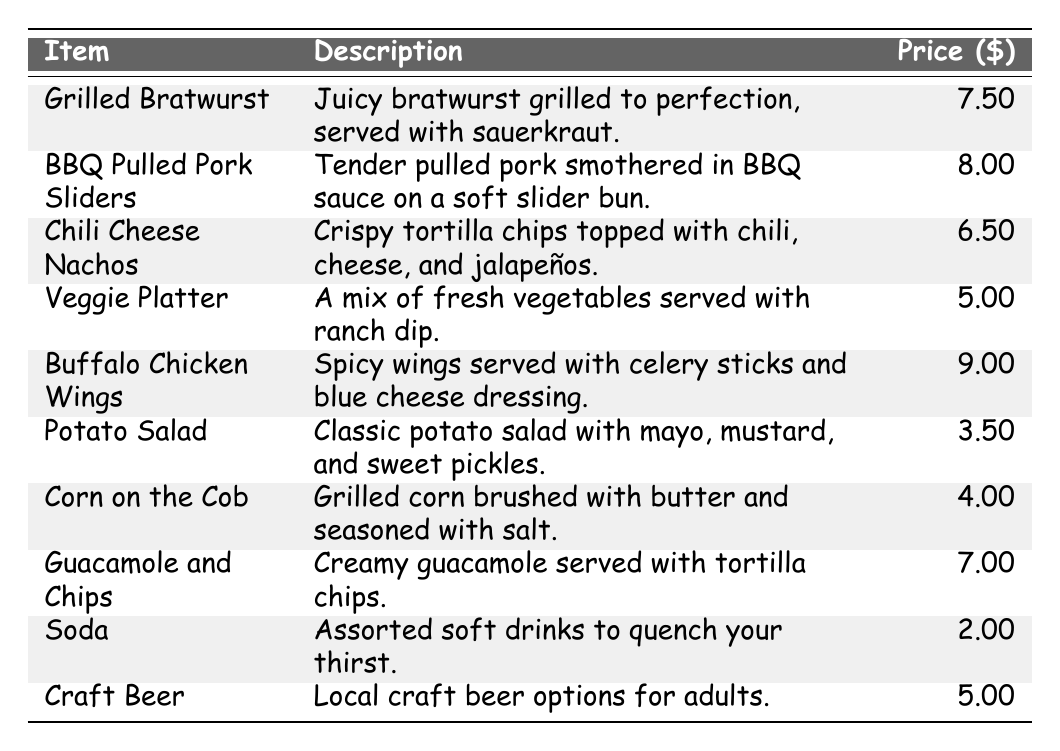What is the price of the Grilled Bratwurst? The table shows that the price listed next to Grilled Bratwurst is $7.50.
Answer: $7.50 How much do the BBQ Pulled Pork Sliders cost? The price for BBQ Pulled Pork Sliders in the table is shown as $8.00.
Answer: $8.00 Is the Veggie Platter less expensive than the Corn on the Cob? The Veggie Platter costs $5.00 and the Corn on the Cob costs $4.00; since $5.00 is not less than $4.00, the statement is false.
Answer: No What is the total cost of buying one of each item on the menu? The total cost is calculated by adding all the prices: 7.50 + 8.00 + 6.50 + 5.00 + 9.00 + 3.50 + 4.00 + 7.00 + 2.00 + 5.00 = 58.50.
Answer: $58.50 How much more expensive are the Buffalo Chicken Wings compared to the Chili Cheese Nachos? The Buffalo Chicken Wings cost $9.00 and the Chili Cheese Nachos cost $6.50. The difference is $9.00 - $6.50 = $2.50.
Answer: $2.50 What is the average price of the items that are priced above $6.00? The items priced above $6.00 are Grilled Bratwurst ($7.50), BBQ Pulled Pork Sliders ($8.00), Buffalo Chicken Wings ($9.00), and Guacamole and Chips ($7.00). The total cost is 7.50 + 8.00 + 9.00 + 7.00 = 31.50. There are 4 items, so the average is 31.50 / 4 = 7.88.
Answer: $7.88 Are there more items priced above $5.00 or below $5.00? The items above $5.00 are Grilled Bratwurst, BBQ Pulled Pork Sliders, Chili Cheese Nachos, Buffalo Chicken Wings, and Guacamole and Chips, totaling 5 items. The items below $5.00 are Potato Salad, Corn on the Cob, and Soda, totaling 3 items. Since 5 is greater than 3, the answer is yes.
Answer: Yes What is the least expensive item on the menu? The least expensive item is the Potato Salad, priced at $3.50, which can be directly identified from the table.
Answer: Potato Salad If you buy 3 sodas, what is the total cost? Each soda costs $2.00, so for 3 sodas the total cost is 3 x 2.00 = 6.00.
Answer: $6.00 How many items on the menu have a price greater than $6.00? The items above $6.00 are Grilled Bratwurst, BBQ Pulled Pork Sliders, Buffalo Chicken Wings, and Guacamole and Chips, which counts to a total of 4 items.
Answer: 4 